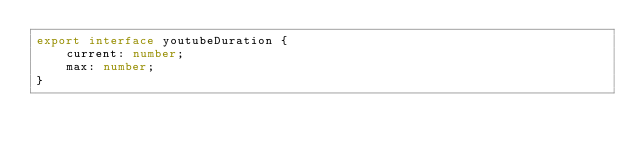Convert code to text. <code><loc_0><loc_0><loc_500><loc_500><_TypeScript_>export interface youtubeDuration {
	current: number;
	max: number;
}
</code> 